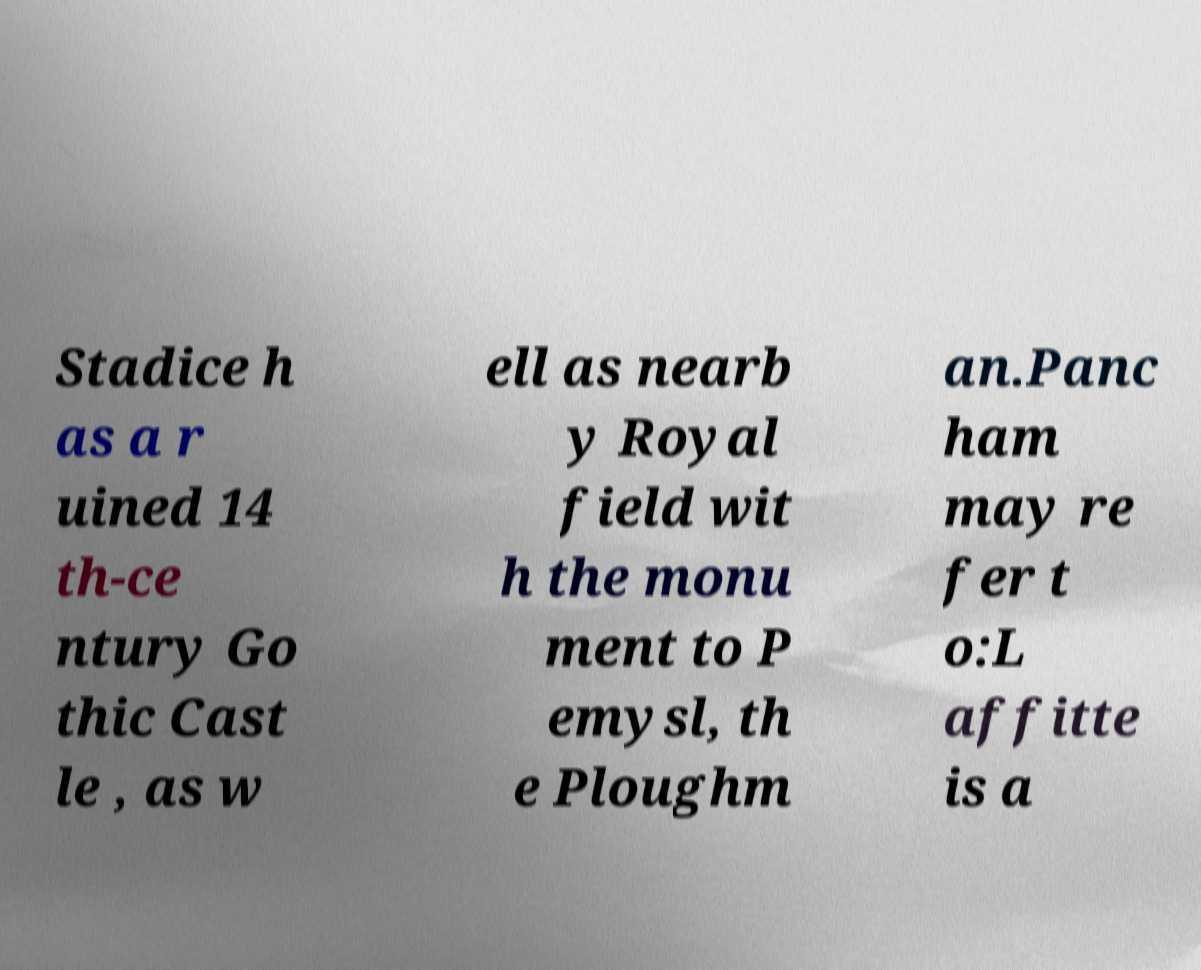Please identify and transcribe the text found in this image. Stadice h as a r uined 14 th-ce ntury Go thic Cast le , as w ell as nearb y Royal field wit h the monu ment to P emysl, th e Ploughm an.Panc ham may re fer t o:L affitte is a 